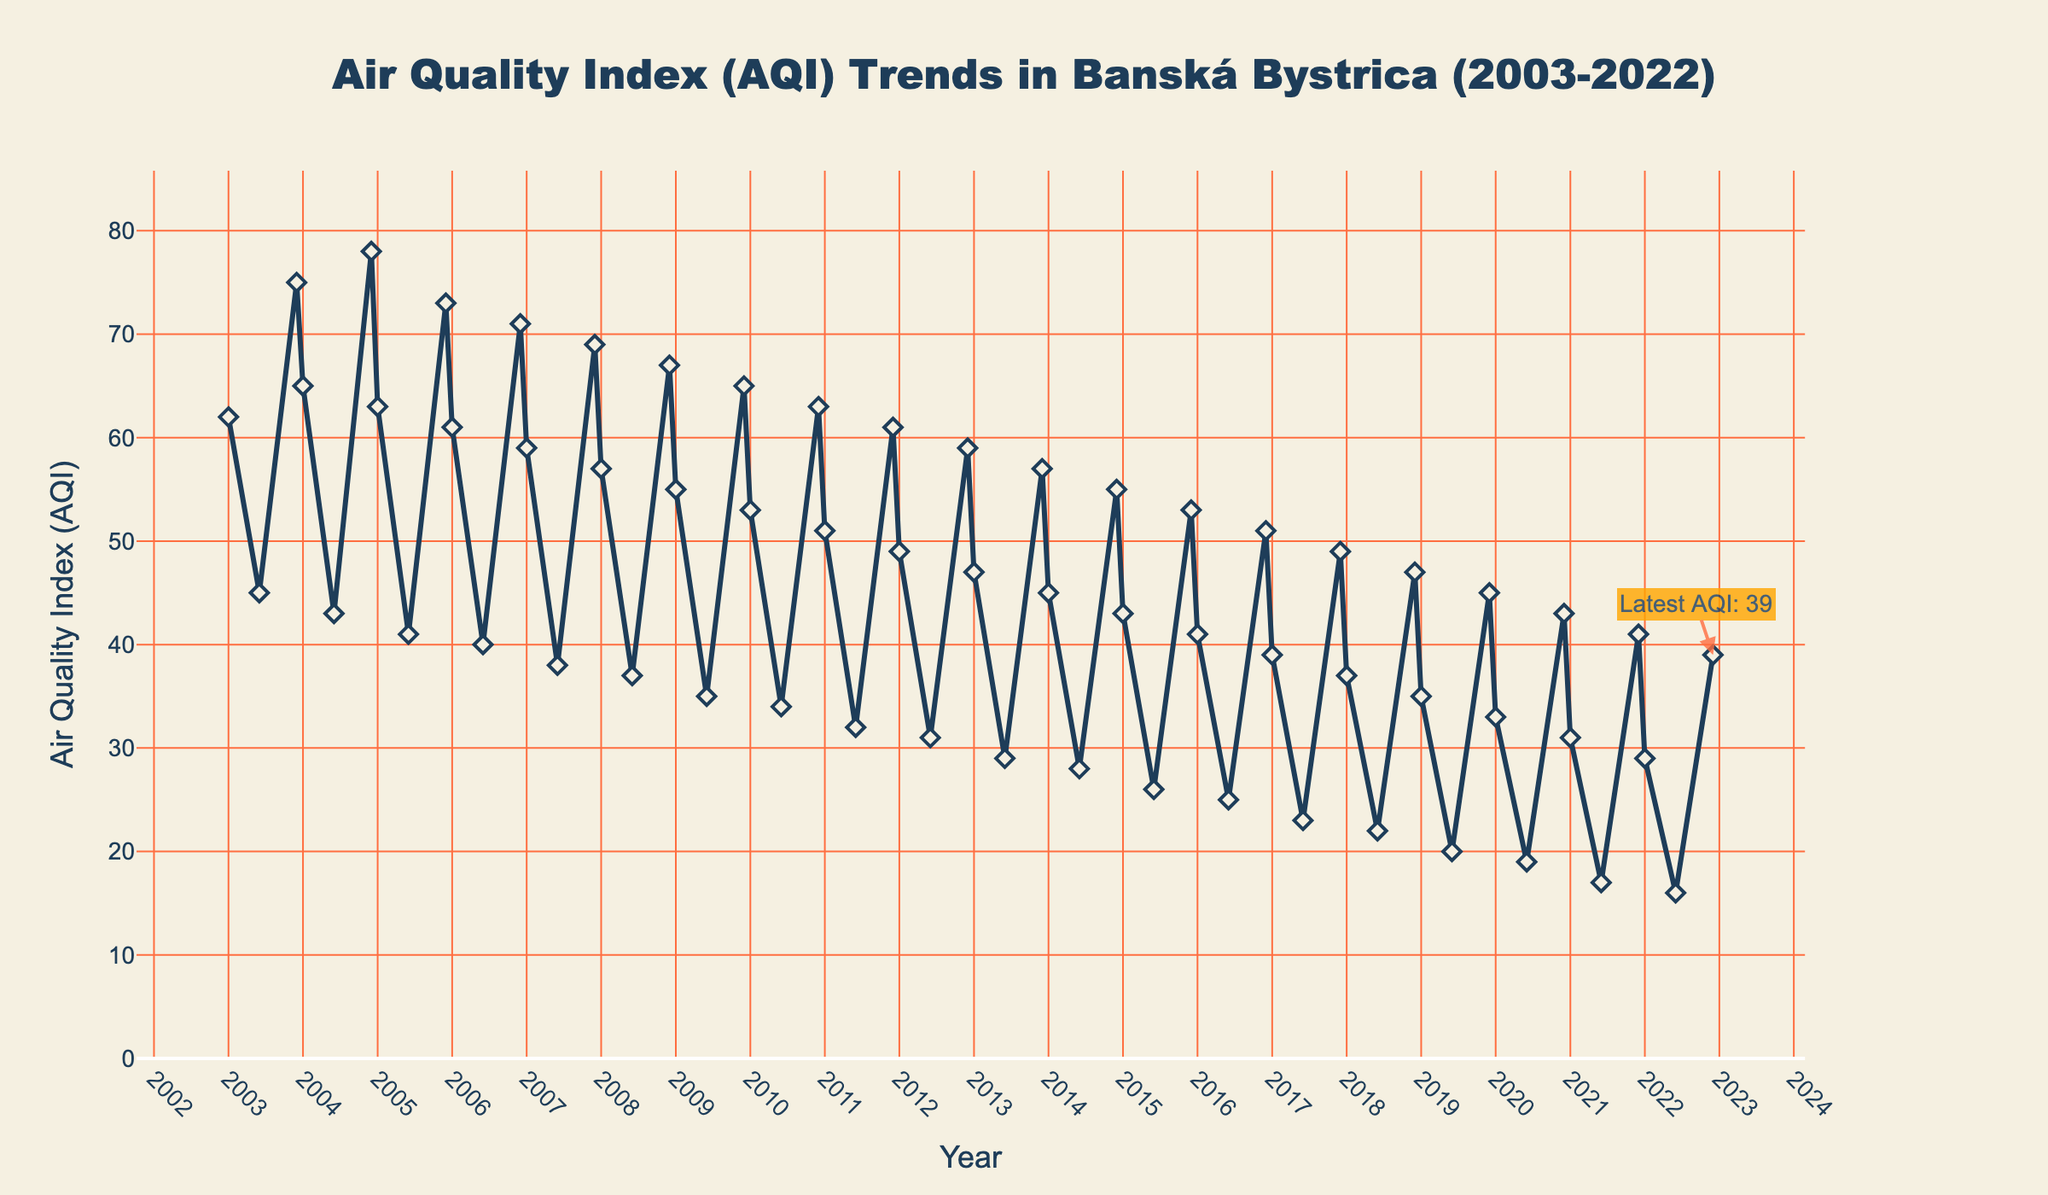What is the overall trend in the Air Quality Index from 2003 to 2022? The overall trend can be inferred by observing the line chart from left to right. The AQI values appear to decrease steadily over the years.
Answer: Decreasing trend How does the AQI in January of 2003 compare to January of 2022? Locate the AQI values for January in both 2003 and 2022 on the chart. In 2003, it's around 62, and in 2022, it's around 29. The value has decreased significantly.
Answer: Lower in 2022 What is the average AQI for the months of June from 2003 to 2022? Collect the AQI values for June from each year, sum them up and divide by the number of years: (45+43+41...+16)/20. The sum is 495 and the average is 495/20=24.75
Answer: 24.75 Has the maximum AQI for December changed over the two decades? Compare the highest AQI values in December throughout the years. Observe the peaks and note the highest value for December from 2003 (75) and 2022 (39). The highest peak decreases.
Answer: Decreased Which year had the lowest AQI in June? Identify the points corresponding to June each year and find the lowest value visually. The lowest value can be seen in June 2022 with an AQI of 16.
Answer: 2022 How does the AQI in July compare to the AQI in December in the year 2015? Check the chart for AQI values in July and December 2015. July data is not provided, but June can be approximated, which is 26, and December is 53. Comparison shows December is higher.
Answer: Higher in December 2015 What can you infer about seasonal trends in AQI? Observe the monthly data points for each year. Summers (June) generally have lower AQI values, while winters (December, January) have higher values. This suggests better air quality in summer and worse in winter.
Answer: Lower in summer, higher in winter What is the approximate change in AQI from January to December in 2020? Locate AQI in January 2020 (33) and December 2020 (43). Calculate the difference (43 - 33).
Answer: Increase of 10 What year shows the most significant annual improvement in AQI from January to December? Look for the year where the decrease from January to December is the most prominent. 2022 shows a significant drop from January (29) to December (39).
Answer: 2022 Which month and year recorded the highest AQI value? Find the highest peak in the entire data range on the chart. It's in December 2004 with an AQI of 78.
Answer: December 2004 